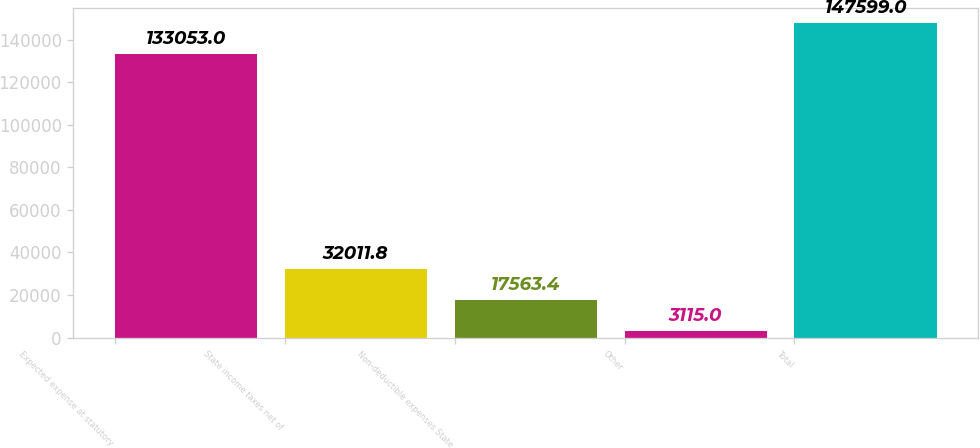Convert chart to OTSL. <chart><loc_0><loc_0><loc_500><loc_500><bar_chart><fcel>Expected expense at statutory<fcel>State income taxes net of<fcel>Non-deductible expenses State<fcel>Other<fcel>Total<nl><fcel>133053<fcel>32011.8<fcel>17563.4<fcel>3115<fcel>147599<nl></chart> 